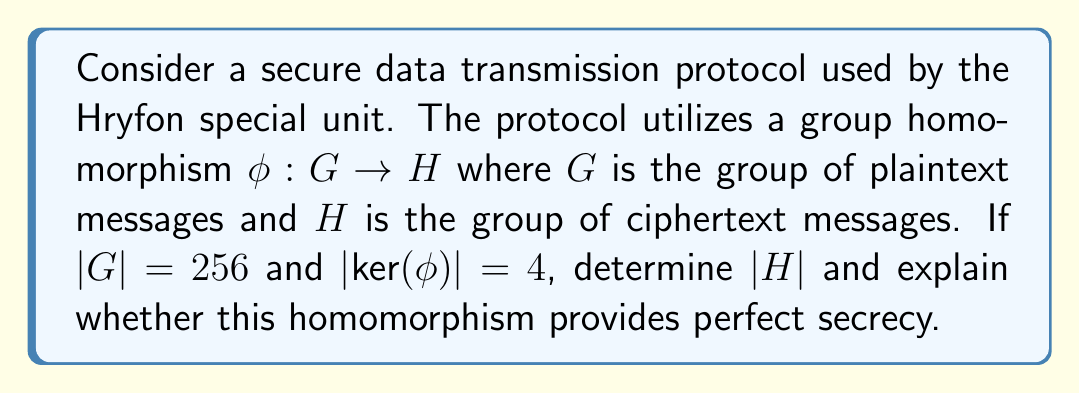Solve this math problem. To solve this problem, we'll use the First Isomorphism Theorem and our knowledge of group homomorphisms:

1) The First Isomorphism Theorem states that for a group homomorphism $\phi: G \rightarrow H$, we have:

   $$G/\text{ker}(\phi) \cong \text{Im}(\phi)$$

2) This implies that:

   $$|\text{Im}(\phi)| = |G|/|\text{ker}(\phi)|$$

3) We're given that $|G| = 256$ and $|\text{ker}(\phi)| = 4$. Substituting these values:

   $$|\text{Im}(\phi)| = 256/4 = 64$$

4) Since $\text{Im}(\phi)$ is a subgroup of $H$, we know that $|H| \geq |\text{Im}(\phi)| = 64$

5) In this case, $|H| = |\text{Im}(\phi)| = 64$, because the homomorphism maps G onto H.

6) To determine if this provides perfect secrecy, we need to consider the definition: A cryptosystem has perfect secrecy if the ciphertext gives no information about the plaintext.

7) In this case, each element in H corresponds to 4 elements in G (because $|\text{ker}(\phi)| = 4$). This means that given a ciphertext, there are 4 possible plaintexts, reducing the uncertainty from 256 to 4.

8) Perfect secrecy requires that the probability of each plaintext given a ciphertext is equal to the a priori probability of that plaintext. This is not the case here, so this homomorphism does not provide perfect secrecy.
Answer: $|H| = 64$. This homomorphism does not provide perfect secrecy. 